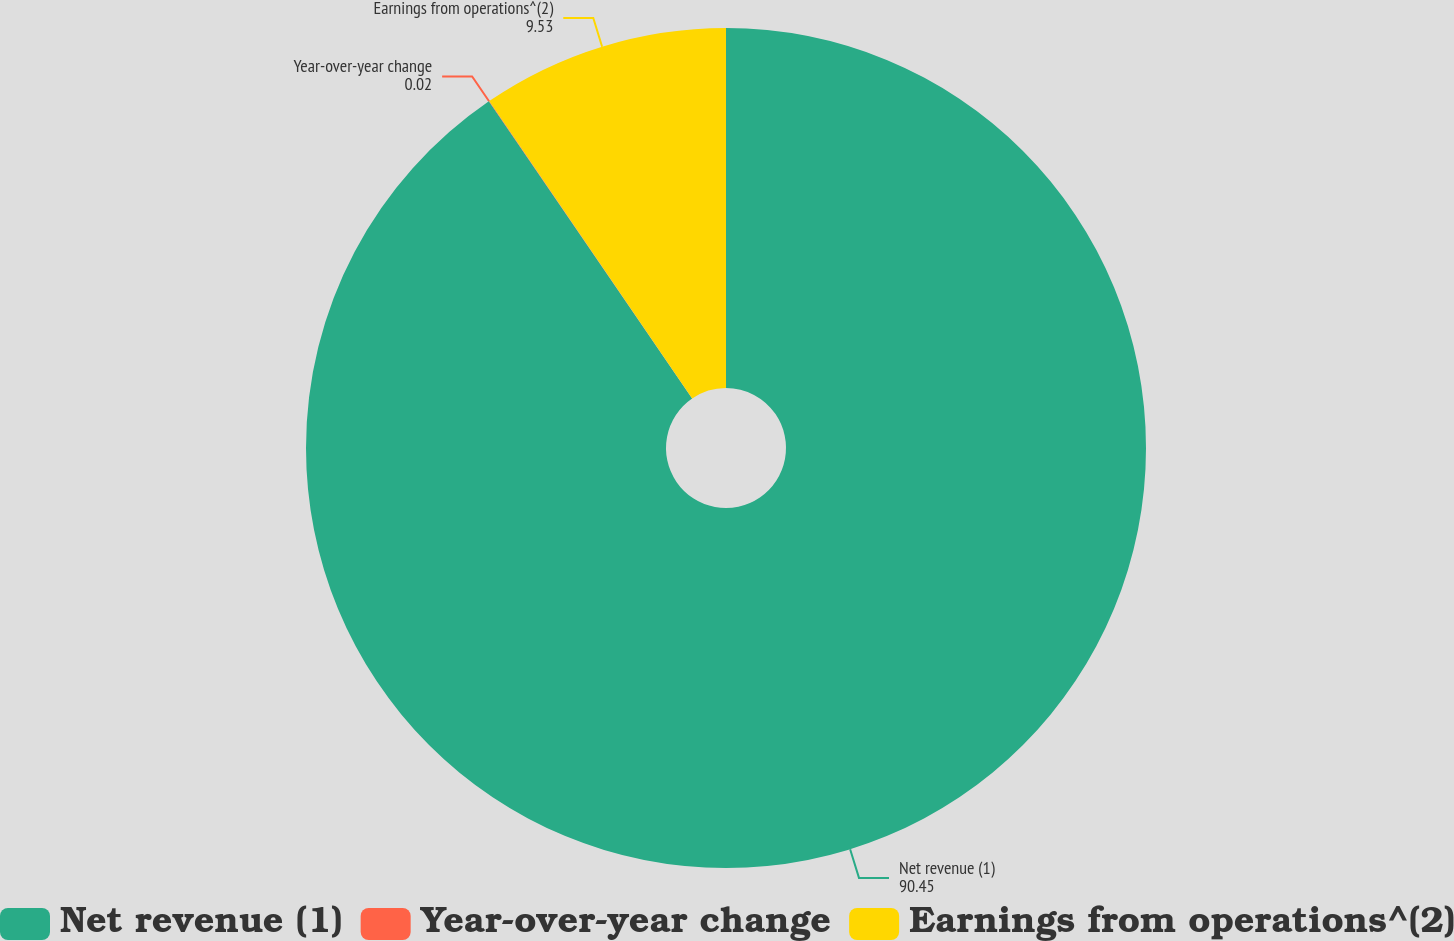<chart> <loc_0><loc_0><loc_500><loc_500><pie_chart><fcel>Net revenue (1)<fcel>Year-over-year change<fcel>Earnings from operations^(2)<nl><fcel>90.45%<fcel>0.02%<fcel>9.53%<nl></chart> 